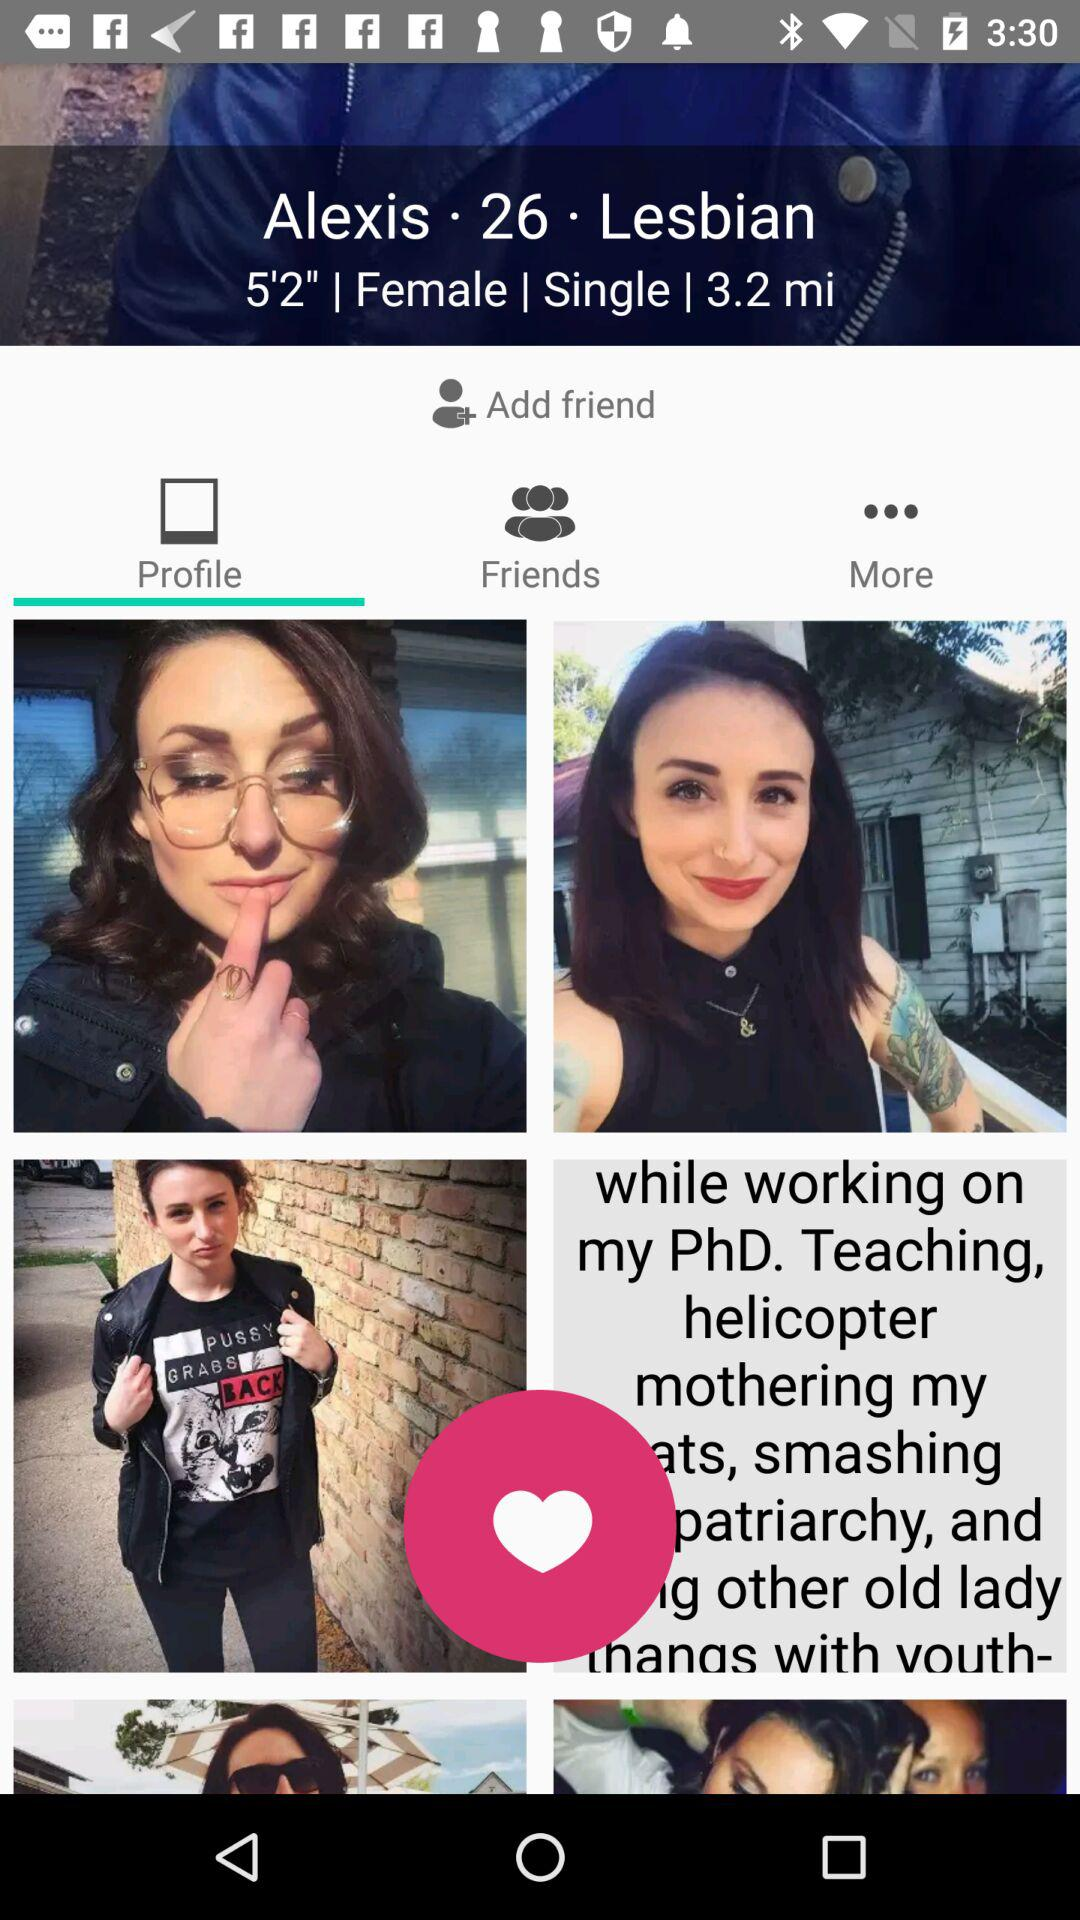What is the distance shown on the screen? The distance is 3.2 miles. 